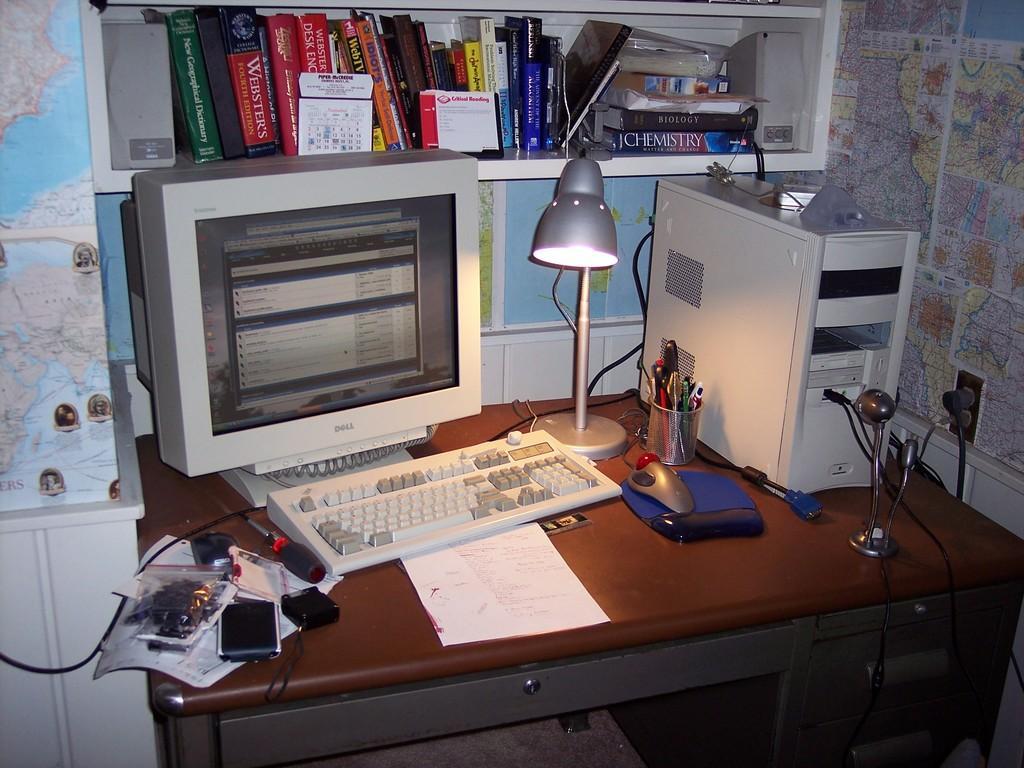How would you summarize this image in a sentence or two? In this picture we can see a desk and on the desk there is a monitor, keyboard, CPU, mouse, mouse pad, pen stand and some objects. On the left and right side of the image, there are maps. Behind the monitor, there are books and some objects in a shelf. 